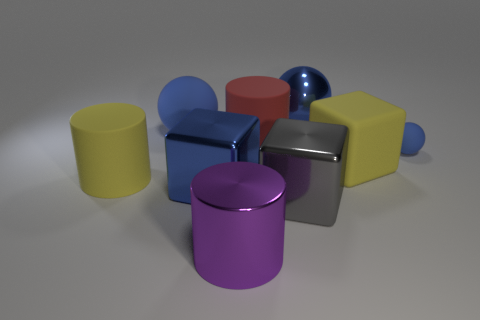How many other objects are the same size as the red matte thing?
Your answer should be very brief. 7. What is the size of the other shiny ball that is the same color as the tiny ball?
Provide a short and direct response. Large. What shape is the tiny thing that is the same color as the shiny ball?
Give a very brief answer. Sphere. How many matte cylinders have the same size as the gray metal thing?
Your answer should be very brief. 2. What is the material of the yellow object that is the same shape as the big purple object?
Your answer should be compact. Rubber. There is a cylinder on the left side of the large blue rubber sphere; what is its color?
Make the answer very short. Yellow. Is the number of big yellow blocks on the left side of the blue metal ball greater than the number of large matte cubes?
Offer a very short reply. No. The big shiny cylinder has what color?
Provide a short and direct response. Purple. The metal object that is behind the large blue metallic object that is left of the big blue sphere right of the large purple metal cylinder is what shape?
Make the answer very short. Sphere. There is a large blue thing that is on the left side of the large red matte cylinder and behind the red rubber cylinder; what material is it made of?
Make the answer very short. Rubber. 